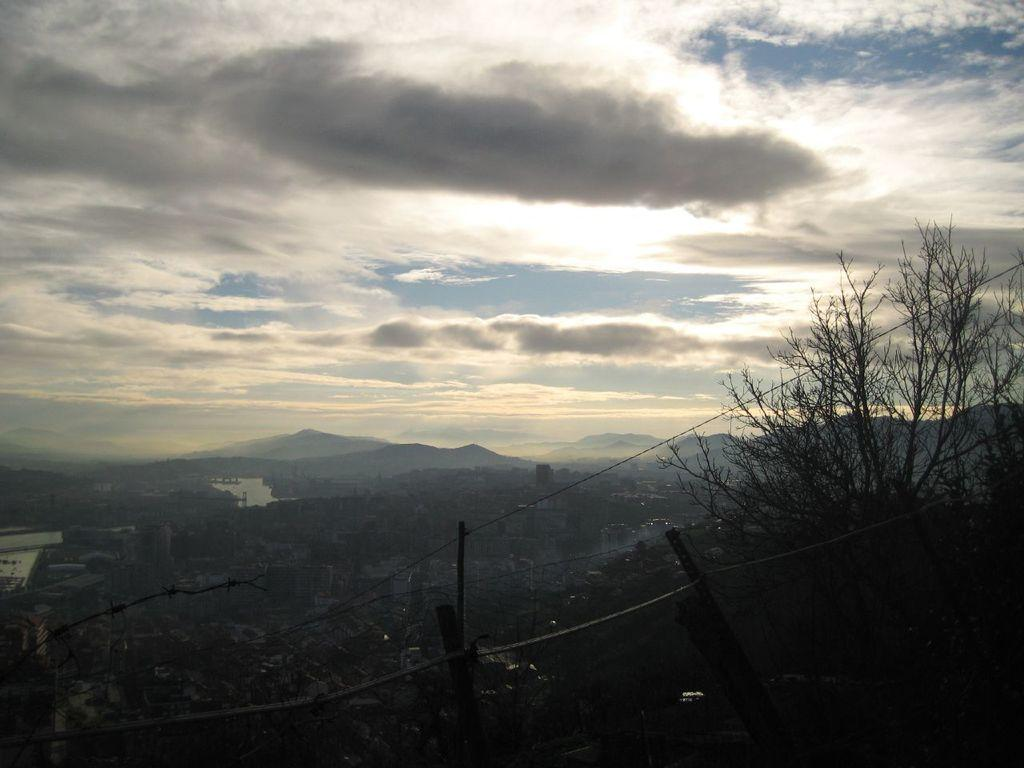What type of natural elements can be seen in the image? A: There are trees in the image. What type of man-made structures are present in the image? There are buildings in the image. What type of geographical feature can be seen in the image? There are hills in the image. What is visible in the background of the image? The sky is visible in the background of the image. Can you tell me how many brushes are used to paint the clams in the image? There are no brushes or clams present in the image; it features trees, buildings, hills, and the sky. 